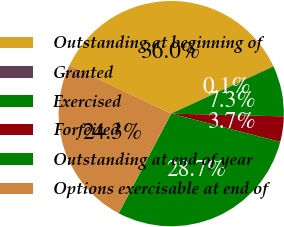Convert chart to OTSL. <chart><loc_0><loc_0><loc_500><loc_500><pie_chart><fcel>Outstanding at beginning of<fcel>Granted<fcel>Exercised<fcel>Forfeited<fcel>Outstanding at end of year<fcel>Options exercisable at end of<nl><fcel>36.02%<fcel>0.06%<fcel>7.25%<fcel>3.65%<fcel>28.68%<fcel>24.33%<nl></chart> 